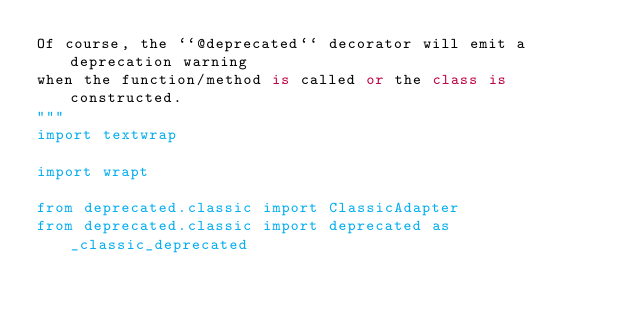Convert code to text. <code><loc_0><loc_0><loc_500><loc_500><_Python_>Of course, the ``@deprecated`` decorator will emit a deprecation warning
when the function/method is called or the class is constructed.
"""
import textwrap

import wrapt

from deprecated.classic import ClassicAdapter
from deprecated.classic import deprecated as _classic_deprecated

</code> 